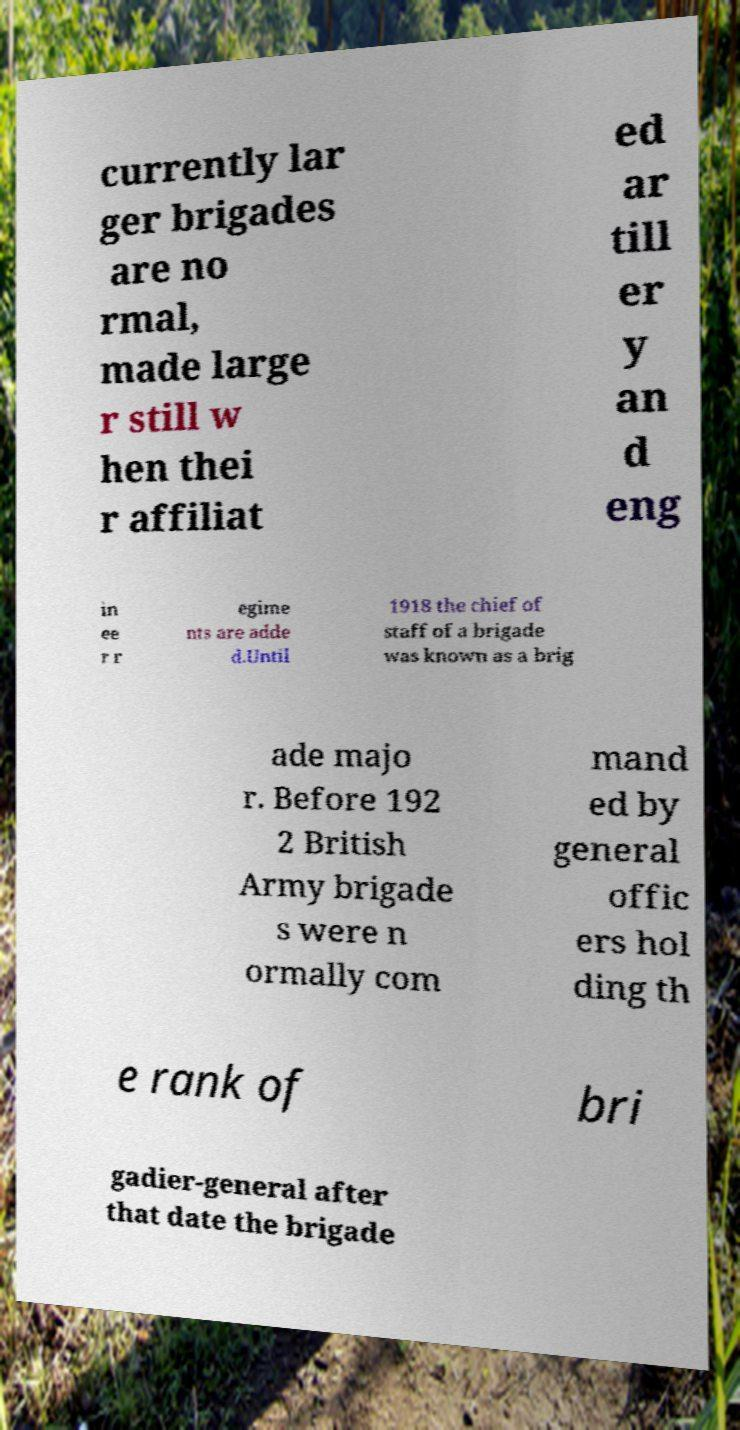There's text embedded in this image that I need extracted. Can you transcribe it verbatim? currently lar ger brigades are no rmal, made large r still w hen thei r affiliat ed ar till er y an d eng in ee r r egime nts are adde d.Until 1918 the chief of staff of a brigade was known as a brig ade majo r. Before 192 2 British Army brigade s were n ormally com mand ed by general offic ers hol ding th e rank of bri gadier-general after that date the brigade 